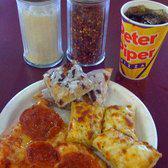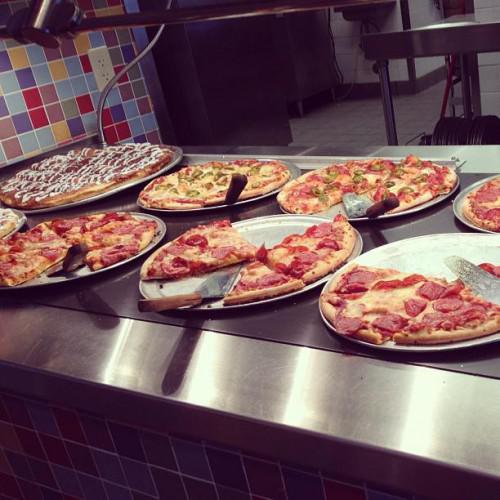The first image is the image on the left, the second image is the image on the right. Given the left and right images, does the statement "There are no cut pizzas in the left image." hold true? Answer yes or no. No. The first image is the image on the left, the second image is the image on the right. For the images displayed, is the sentence "People stand along a buffet in one of the images." factually correct? Answer yes or no. No. 